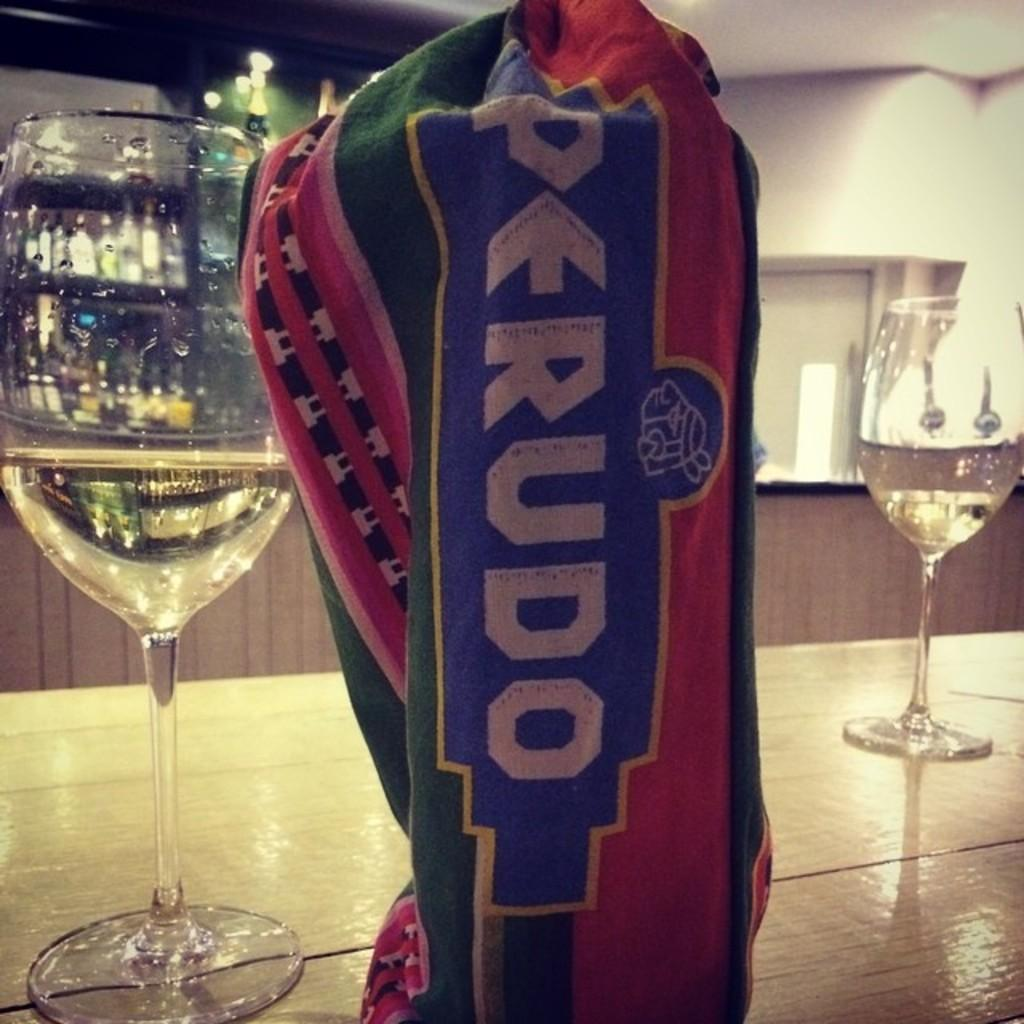<image>
Provide a brief description of the given image. A bar has two wine glasses on it and a shirt that says Perudo is wrapped around a glass. 